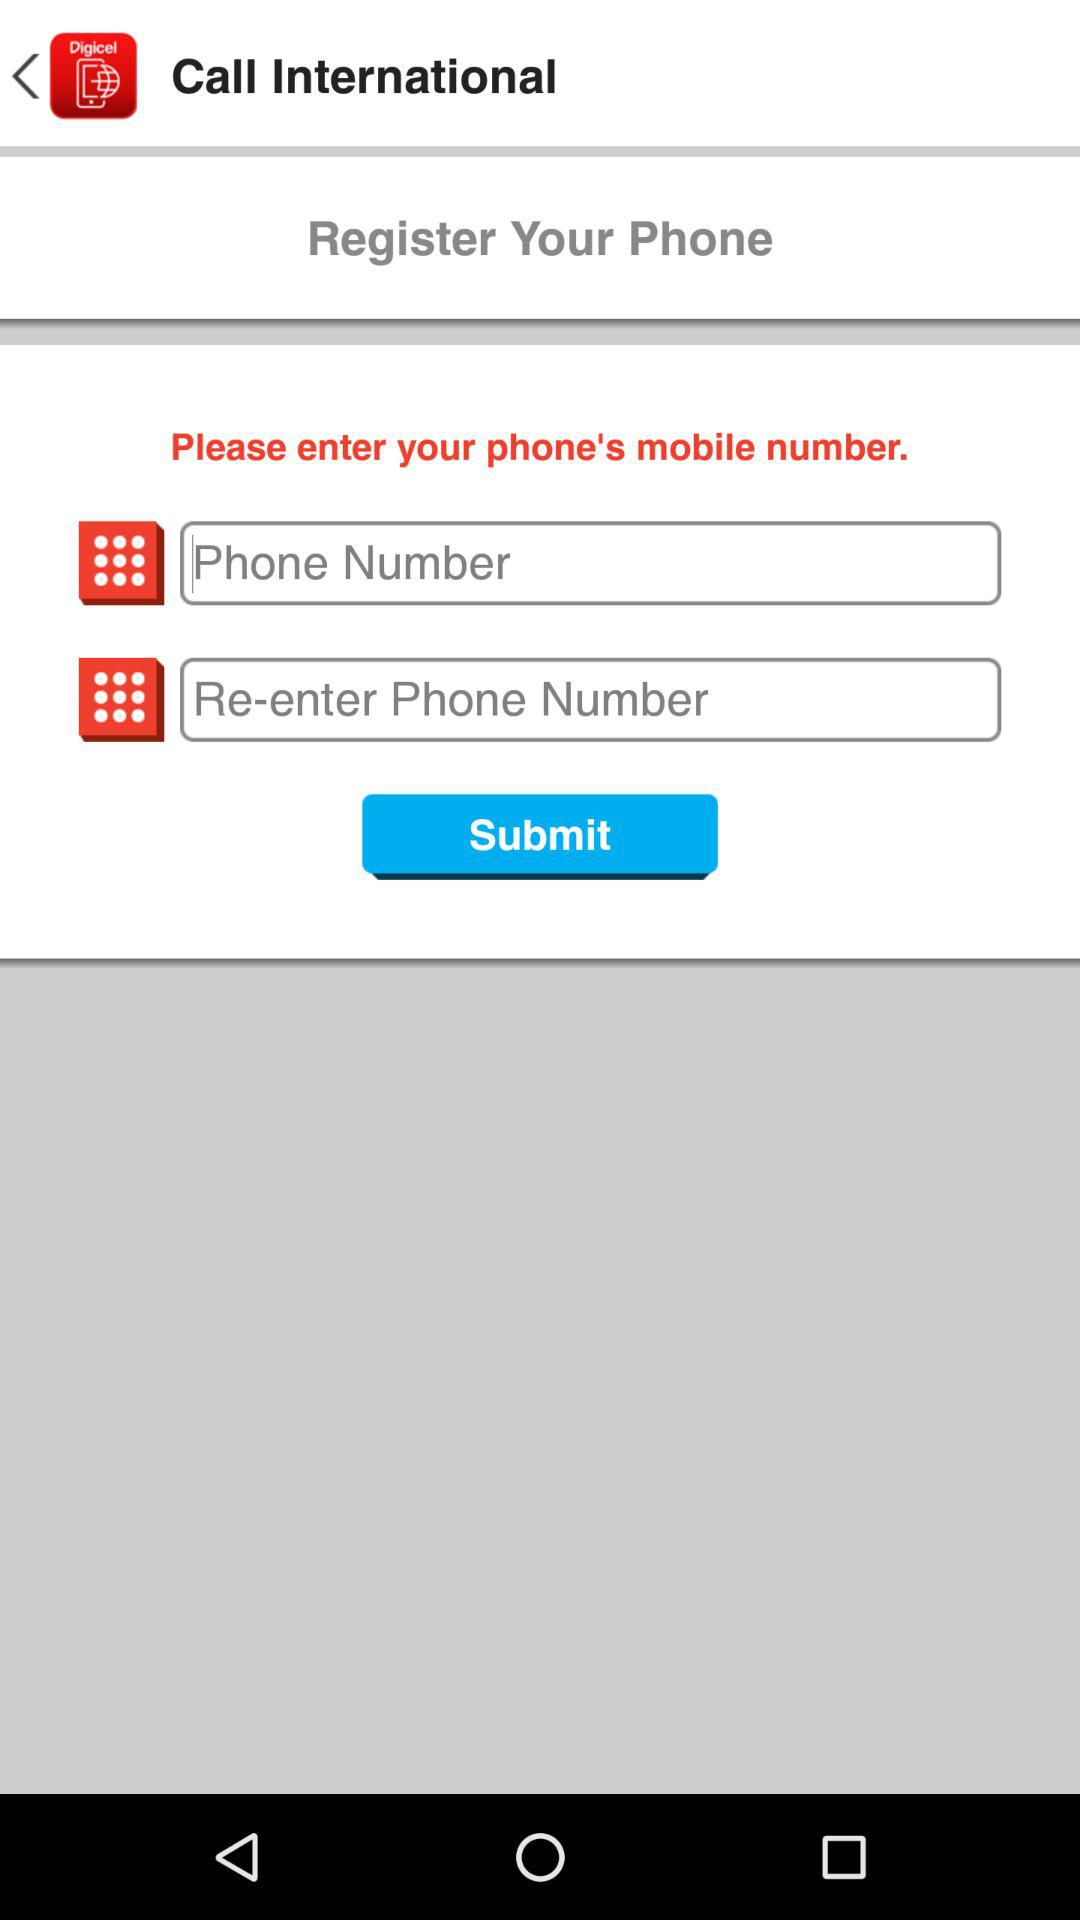How many text input fields are there on this page?
Answer the question using a single word or phrase. 2 